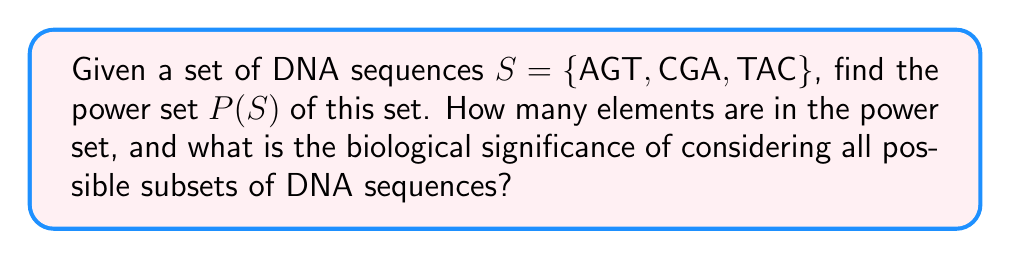Help me with this question. To solve this problem, let's break it down into steps:

1. Recall the definition of a power set:
   The power set P(S) of a set S is the set of all possible subsets of S, including the empty set and S itself.

2. For a set with n elements, the number of elements in its power set is given by $2^n$.

3. In our case, |S| = 3, so the number of elements in P(S) will be $2^3 = 8$.

4. Let's list all the subsets:
   - Empty set: ∅
   - Single element subsets: {AGT}, {CGA}, {TAC}
   - Two-element subsets: {AGT, CGA}, {AGT, TAC}, {CGA, TAC}
   - The full set: {AGT, CGA, TAC}

5. Therefore, P(S) = {∅, {AGT}, {CGA}, {TAC}, {AGT, CGA}, {AGT, TAC}, {CGA, TAC}, {AGT, CGA, TAC}}

Biological significance:
Considering all possible subsets of DNA sequences is important in bioinformatics for several reasons:

a) Motif analysis: Subsets can represent potential binding sites or regulatory elements.
b) Evolutionary studies: Comparing subsets can help identify conserved regions across species.
c) PCR primer design: Subsets can be used to find unique sequence combinations for specific amplification.
d) Sequence assembly: Overlapping subsets aid in reconstructing longer sequences from shorter reads.
e) Mutation analysis: Subsets can represent various mutation combinations in a population.

By examining the power set, researchers can systematically explore all possible combinations of sequences, which is crucial for comprehensive analysis in many bioinformatics applications.
Answer: The power set P(S) = {∅, {AGT}, {CGA}, {TAC}, {AGT, CGA}, {AGT, TAC}, {CGA, TAC}, {AGT, CGA, TAC}}

Number of elements in P(S) = $2^3 = 8$ 